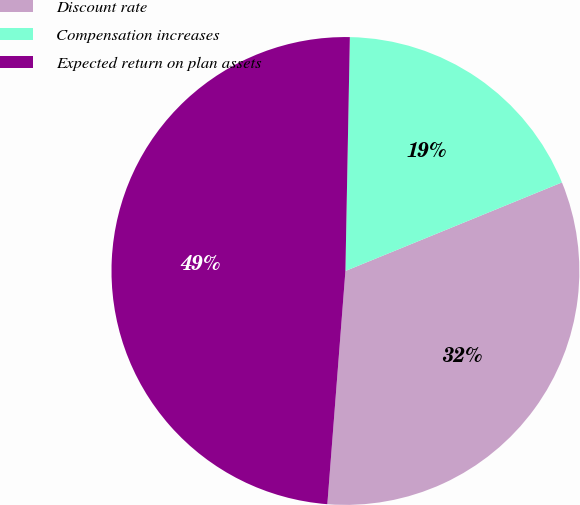<chart> <loc_0><loc_0><loc_500><loc_500><pie_chart><fcel>Discount rate<fcel>Compensation increases<fcel>Expected return on plan assets<nl><fcel>32.41%<fcel>18.52%<fcel>49.07%<nl></chart> 